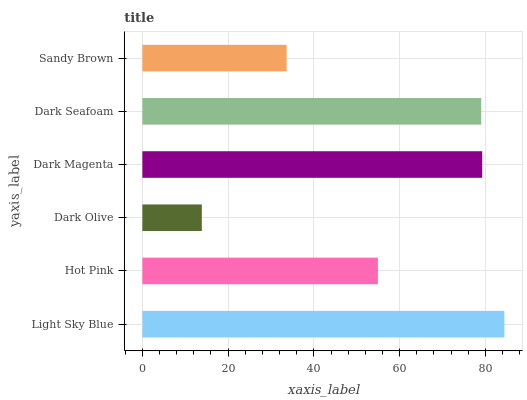Is Dark Olive the minimum?
Answer yes or no. Yes. Is Light Sky Blue the maximum?
Answer yes or no. Yes. Is Hot Pink the minimum?
Answer yes or no. No. Is Hot Pink the maximum?
Answer yes or no. No. Is Light Sky Blue greater than Hot Pink?
Answer yes or no. Yes. Is Hot Pink less than Light Sky Blue?
Answer yes or no. Yes. Is Hot Pink greater than Light Sky Blue?
Answer yes or no. No. Is Light Sky Blue less than Hot Pink?
Answer yes or no. No. Is Dark Seafoam the high median?
Answer yes or no. Yes. Is Hot Pink the low median?
Answer yes or no. Yes. Is Hot Pink the high median?
Answer yes or no. No. Is Sandy Brown the low median?
Answer yes or no. No. 